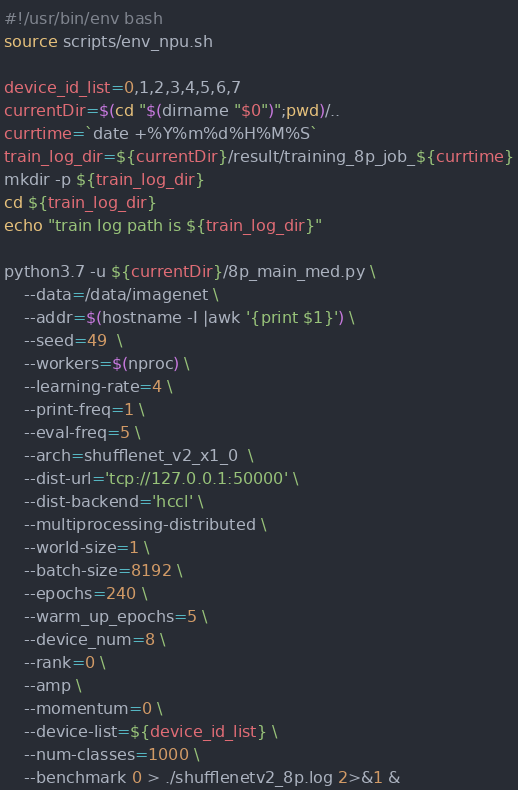<code> <loc_0><loc_0><loc_500><loc_500><_Bash_>#!/usr/bin/env bash
source scripts/env_npu.sh

device_id_list=0,1,2,3,4,5,6,7
currentDir=$(cd "$(dirname "$0")";pwd)/..
currtime=`date +%Y%m%d%H%M%S`
train_log_dir=${currentDir}/result/training_8p_job_${currtime}
mkdir -p ${train_log_dir}
cd ${train_log_dir}
echo "train log path is ${train_log_dir}"

python3.7 -u ${currentDir}/8p_main_med.py \
    --data=/data/imagenet \
    --addr=$(hostname -I |awk '{print $1}') \
    --seed=49  \
    --workers=$(nproc) \
    --learning-rate=4 \
    --print-freq=1 \
    --eval-freq=5 \
    --arch=shufflenet_v2_x1_0  \
    --dist-url='tcp://127.0.0.1:50000' \
    --dist-backend='hccl' \
    --multiprocessing-distributed \
    --world-size=1 \
    --batch-size=8192 \
    --epochs=240 \
    --warm_up_epochs=5 \
    --device_num=8 \
    --rank=0 \
    --amp \
    --momentum=0 \
    --device-list=${device_id_list} \
    --num-classes=1000 \
    --benchmark 0 > ./shufflenetv2_8p.log 2>&1 &
</code> 